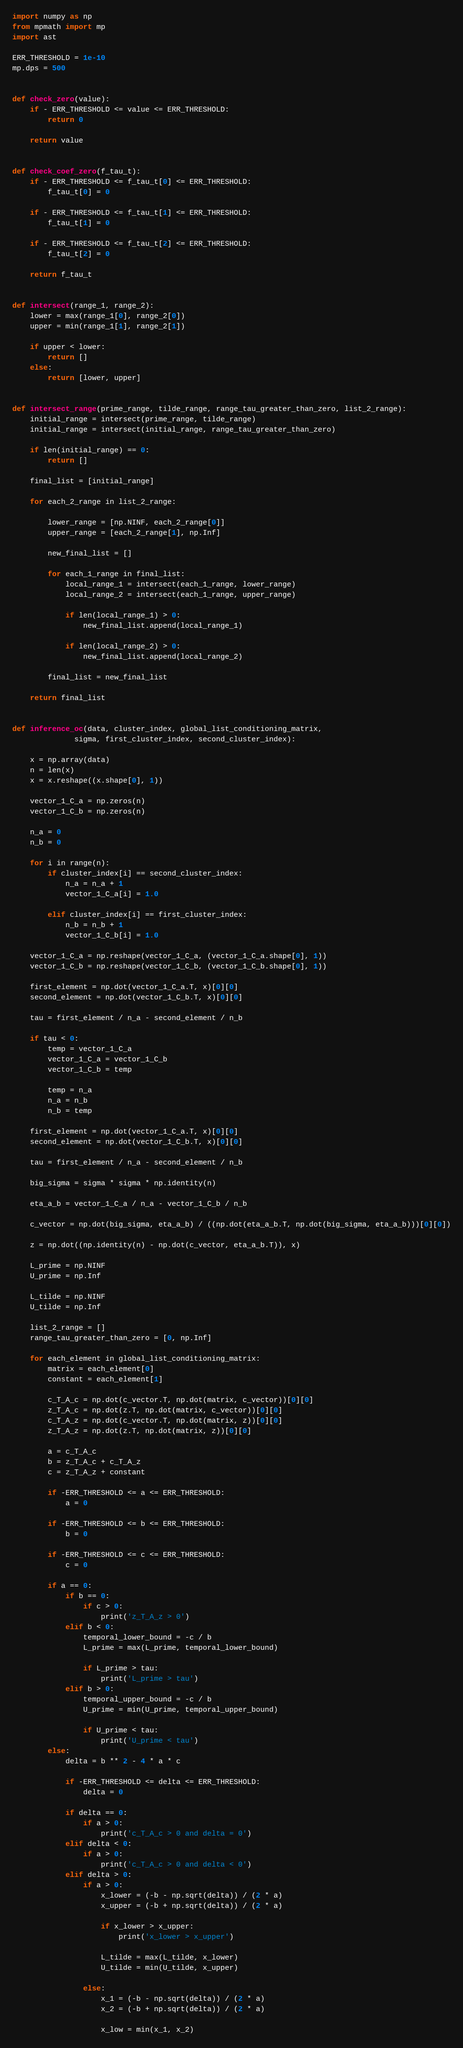<code> <loc_0><loc_0><loc_500><loc_500><_Python_>import numpy as np
from mpmath import mp
import ast

ERR_THRESHOLD = 1e-10
mp.dps = 500


def check_zero(value):
    if - ERR_THRESHOLD <= value <= ERR_THRESHOLD:
        return 0

    return value


def check_coef_zero(f_tau_t):
    if - ERR_THRESHOLD <= f_tau_t[0] <= ERR_THRESHOLD:
        f_tau_t[0] = 0

    if - ERR_THRESHOLD <= f_tau_t[1] <= ERR_THRESHOLD:
        f_tau_t[1] = 0

    if - ERR_THRESHOLD <= f_tau_t[2] <= ERR_THRESHOLD:
        f_tau_t[2] = 0

    return f_tau_t


def intersect(range_1, range_2):
    lower = max(range_1[0], range_2[0])
    upper = min(range_1[1], range_2[1])

    if upper < lower:
        return []
    else:
        return [lower, upper]


def intersect_range(prime_range, tilde_range, range_tau_greater_than_zero, list_2_range):
    initial_range = intersect(prime_range, tilde_range)
    initial_range = intersect(initial_range, range_tau_greater_than_zero)

    if len(initial_range) == 0:
        return []

    final_list = [initial_range]

    for each_2_range in list_2_range:

        lower_range = [np.NINF, each_2_range[0]]
        upper_range = [each_2_range[1], np.Inf]

        new_final_list = []

        for each_1_range in final_list:
            local_range_1 = intersect(each_1_range, lower_range)
            local_range_2 = intersect(each_1_range, upper_range)

            if len(local_range_1) > 0:
                new_final_list.append(local_range_1)

            if len(local_range_2) > 0:
                new_final_list.append(local_range_2)

        final_list = new_final_list

    return final_list


def inference_oc(data, cluster_index, global_list_conditioning_matrix,
              sigma, first_cluster_index, second_cluster_index):

    x = np.array(data)
    n = len(x)
    x = x.reshape((x.shape[0], 1))

    vector_1_C_a = np.zeros(n)
    vector_1_C_b = np.zeros(n)

    n_a = 0
    n_b = 0

    for i in range(n):
        if cluster_index[i] == second_cluster_index:
            n_a = n_a + 1
            vector_1_C_a[i] = 1.0

        elif cluster_index[i] == first_cluster_index:
            n_b = n_b + 1
            vector_1_C_b[i] = 1.0

    vector_1_C_a = np.reshape(vector_1_C_a, (vector_1_C_a.shape[0], 1))
    vector_1_C_b = np.reshape(vector_1_C_b, (vector_1_C_b.shape[0], 1))

    first_element = np.dot(vector_1_C_a.T, x)[0][0]
    second_element = np.dot(vector_1_C_b.T, x)[0][0]

    tau = first_element / n_a - second_element / n_b

    if tau < 0:
        temp = vector_1_C_a
        vector_1_C_a = vector_1_C_b
        vector_1_C_b = temp

        temp = n_a
        n_a = n_b
        n_b = temp

    first_element = np.dot(vector_1_C_a.T, x)[0][0]
    second_element = np.dot(vector_1_C_b.T, x)[0][0]

    tau = first_element / n_a - second_element / n_b

    big_sigma = sigma * sigma * np.identity(n)

    eta_a_b = vector_1_C_a / n_a - vector_1_C_b / n_b

    c_vector = np.dot(big_sigma, eta_a_b) / ((np.dot(eta_a_b.T, np.dot(big_sigma, eta_a_b)))[0][0])

    z = np.dot((np.identity(n) - np.dot(c_vector, eta_a_b.T)), x)

    L_prime = np.NINF
    U_prime = np.Inf

    L_tilde = np.NINF
    U_tilde = np.Inf

    list_2_range = []
    range_tau_greater_than_zero = [0, np.Inf]

    for each_element in global_list_conditioning_matrix:
        matrix = each_element[0]
        constant = each_element[1]

        c_T_A_c = np.dot(c_vector.T, np.dot(matrix, c_vector))[0][0]
        z_T_A_c = np.dot(z.T, np.dot(matrix, c_vector))[0][0]
        c_T_A_z = np.dot(c_vector.T, np.dot(matrix, z))[0][0]
        z_T_A_z = np.dot(z.T, np.dot(matrix, z))[0][0]

        a = c_T_A_c
        b = z_T_A_c + c_T_A_z
        c = z_T_A_z + constant

        if -ERR_THRESHOLD <= a <= ERR_THRESHOLD:
            a = 0

        if -ERR_THRESHOLD <= b <= ERR_THRESHOLD:
            b = 0

        if -ERR_THRESHOLD <= c <= ERR_THRESHOLD:
            c = 0

        if a == 0:
            if b == 0:
                if c > 0:
                    print('z_T_A_z > 0')
            elif b < 0:
                temporal_lower_bound = -c / b
                L_prime = max(L_prime, temporal_lower_bound)

                if L_prime > tau:
                    print('L_prime > tau')
            elif b > 0:
                temporal_upper_bound = -c / b
                U_prime = min(U_prime, temporal_upper_bound)

                if U_prime < tau:
                    print('U_prime < tau')
        else:
            delta = b ** 2 - 4 * a * c

            if -ERR_THRESHOLD <= delta <= ERR_THRESHOLD:
                delta = 0

            if delta == 0:
                if a > 0:
                    print('c_T_A_c > 0 and delta = 0')
            elif delta < 0:
                if a > 0:
                    print('c_T_A_c > 0 and delta < 0')
            elif delta > 0:
                if a > 0:
                    x_lower = (-b - np.sqrt(delta)) / (2 * a)
                    x_upper = (-b + np.sqrt(delta)) / (2 * a)

                    if x_lower > x_upper:
                        print('x_lower > x_upper')

                    L_tilde = max(L_tilde, x_lower)
                    U_tilde = min(U_tilde, x_upper)

                else:
                    x_1 = (-b - np.sqrt(delta)) / (2 * a)
                    x_2 = (-b + np.sqrt(delta)) / (2 * a)

                    x_low = min(x_1, x_2)</code> 